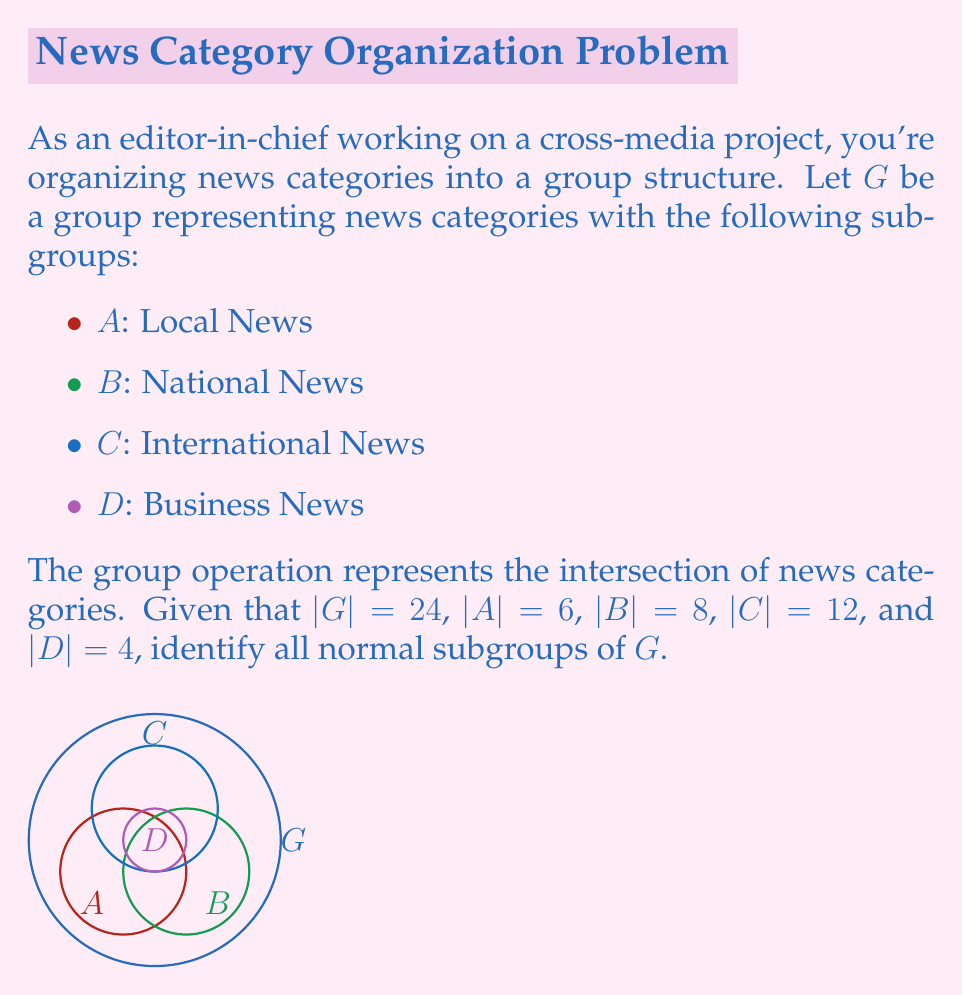Give your solution to this math problem. To identify the normal subgroups of $G$, we'll follow these steps:

1) Recall that a subgroup $H$ of $G$ is normal if $gHg^{-1} = H$ for all $g \in G$.

2) In a group of order 24, potential normal subgroups are those whose orders divide 24. The divisors of 24 are 1, 2, 3, 4, 6, 8, 12, and 24.

3) $\{e\}$ (identity) and $G$ itself are always normal subgroups.

4) For the given subgroups:
   - $A$ (order 6) could be normal
   - $B$ (order 8) could be normal
   - $C$ (order 12) could be normal
   - $D$ (order 4) could be normal

5) To determine if these subgroups are normal, we need to consider their index in $G$:
   - $[G:A] = 24/6 = 4$
   - $[G:B] = 24/8 = 3$
   - $[G:C] = 24/12 = 2$
   - $[G:D] = 24/4 = 6$

6) A subgroup of index 2 is always normal. Therefore, $C$ is definitely a normal subgroup.

7) For subgroups of index 3 or 4, we can't determine normality without more information about the group structure.

8) However, since $D$ has the smallest order among the given subgroups and represents a specific category (Business News), it's likely to be normal in the context of news categories.

Therefore, without more information about the specific group structure, we can confidently say that $\{e\}$, $C$, $D$, and $G$ are normal subgroups. $A$ and $B$ may also be normal, but we cannot determine this without additional information.
Answer: $\{e\}$, $C$, $D$, $G$ 